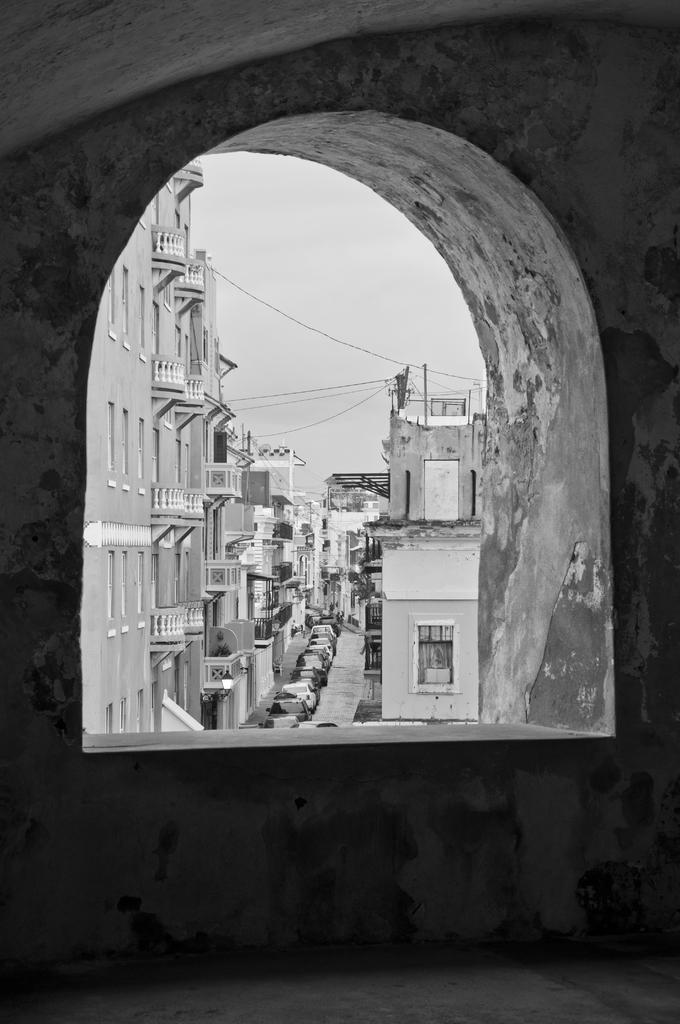What is the color scheme of the image? The image is black and white. What can be seen inside the room in the image? There is a window in the image. What is visible through the window? Buildings, windows of the buildings, vehicles, and a grille are visible through the window. What is visible outside the room in the image? The sky is visible in the image. What is the title of the book that the person is reading in the image? There is no person or book visible in the image. How does the swing affect the temper of the person in the image? There is no swing or person present in the image. 